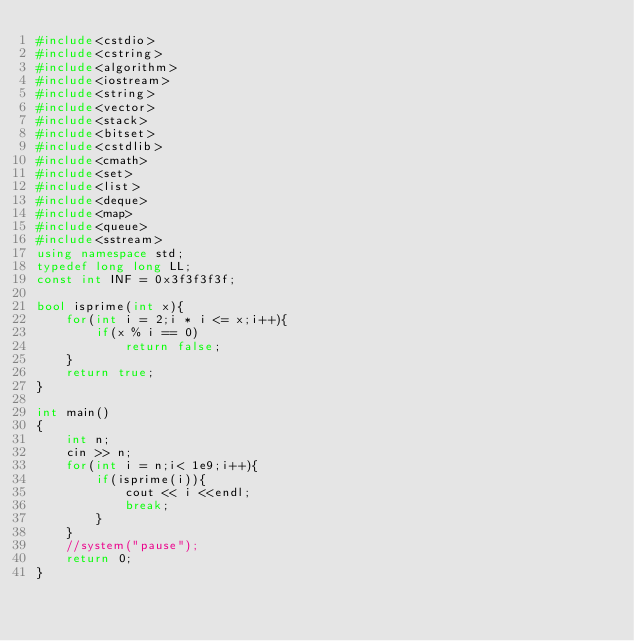Convert code to text. <code><loc_0><loc_0><loc_500><loc_500><_C++_>#include<cstdio>
#include<cstring>
#include<algorithm>
#include<iostream>
#include<string>
#include<vector>
#include<stack>
#include<bitset>
#include<cstdlib>
#include<cmath>
#include<set>
#include<list>
#include<deque>
#include<map>
#include<queue>
#include<sstream>
using namespace std;
typedef long long LL;
const int INF = 0x3f3f3f3f;

bool isprime(int x){
    for(int i = 2;i * i <= x;i++){
        if(x % i == 0)
            return false;
    }
    return true;
}

int main()
{
    int n;
    cin >> n;
    for(int i = n;i< 1e9;i++){
        if(isprime(i)){
            cout << i <<endl;
            break;
        }
    }
    //system("pause");
    return 0;
}</code> 